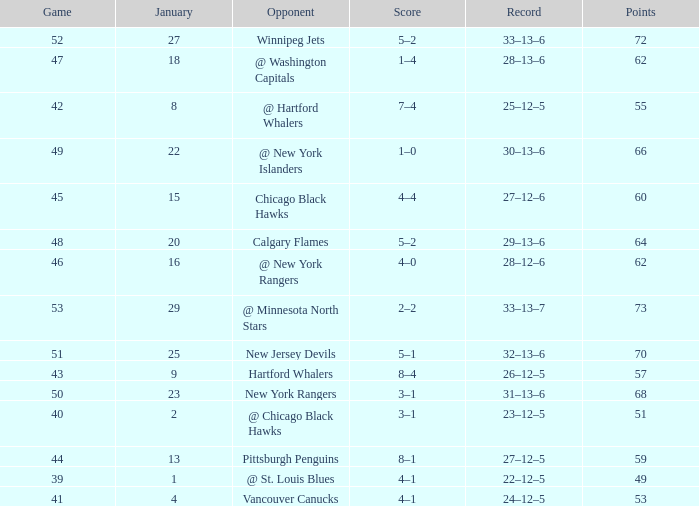How many games have a Score of 1–0, and Points smaller than 66? 0.0. 